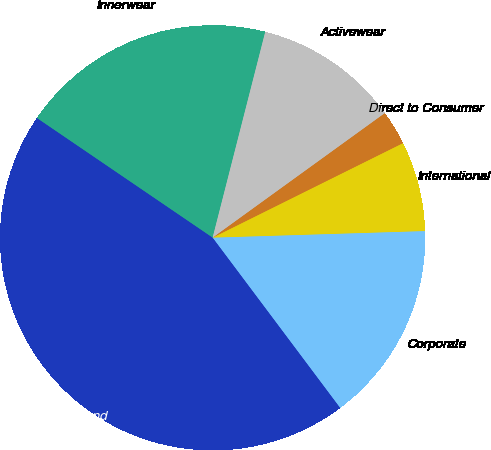<chart> <loc_0><loc_0><loc_500><loc_500><pie_chart><fcel>Innerwear<fcel>Activewear<fcel>Direct to Consumer<fcel>International<fcel>Corporate<fcel>Total depreciation and<nl><fcel>19.47%<fcel>11.05%<fcel>2.63%<fcel>6.84%<fcel>15.26%<fcel>44.74%<nl></chart> 